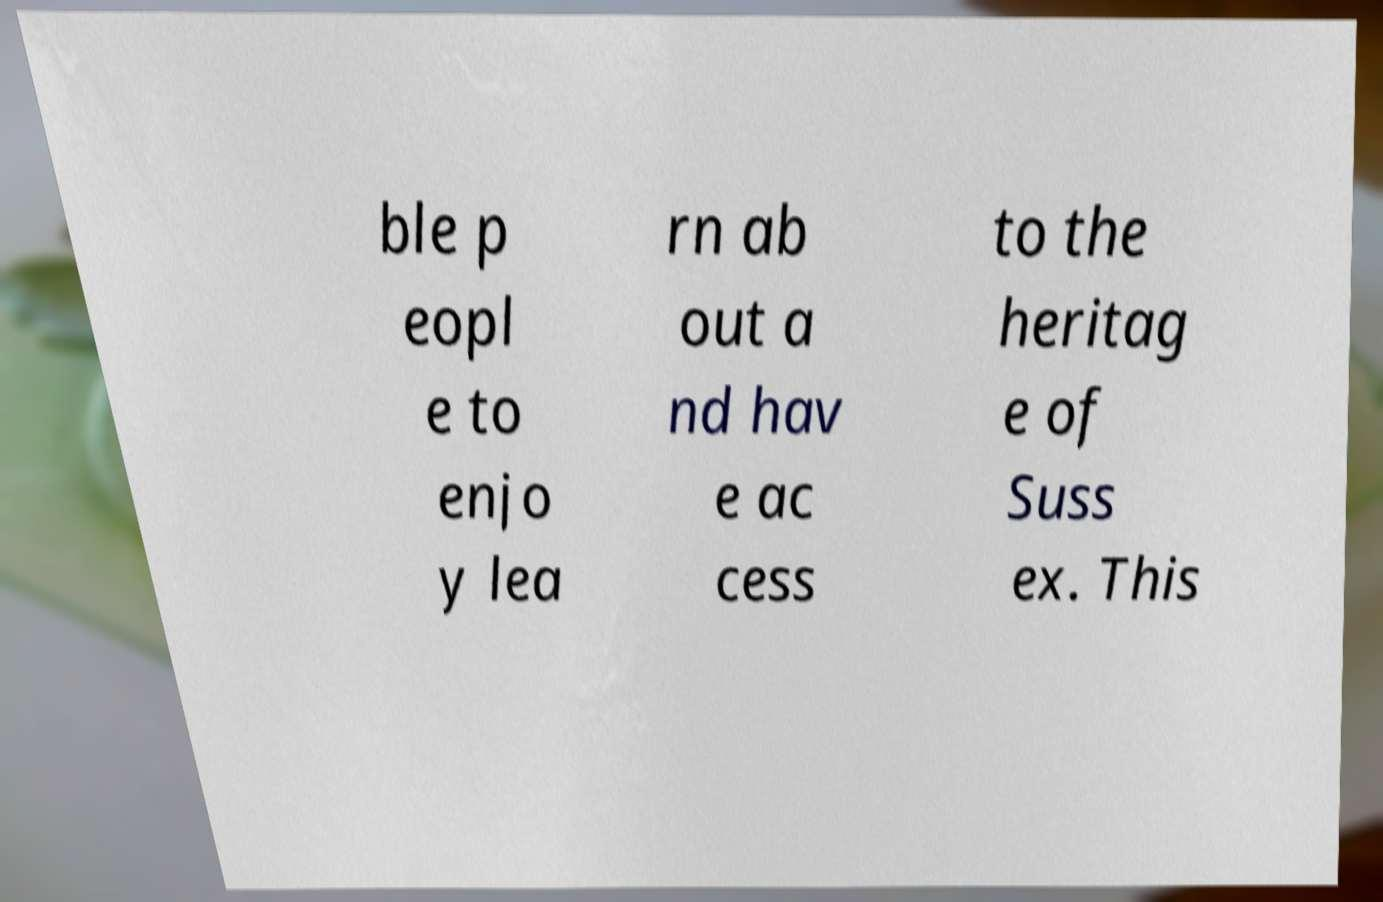Could you extract and type out the text from this image? ble p eopl e to enjo y lea rn ab out a nd hav e ac cess to the heritag e of Suss ex. This 